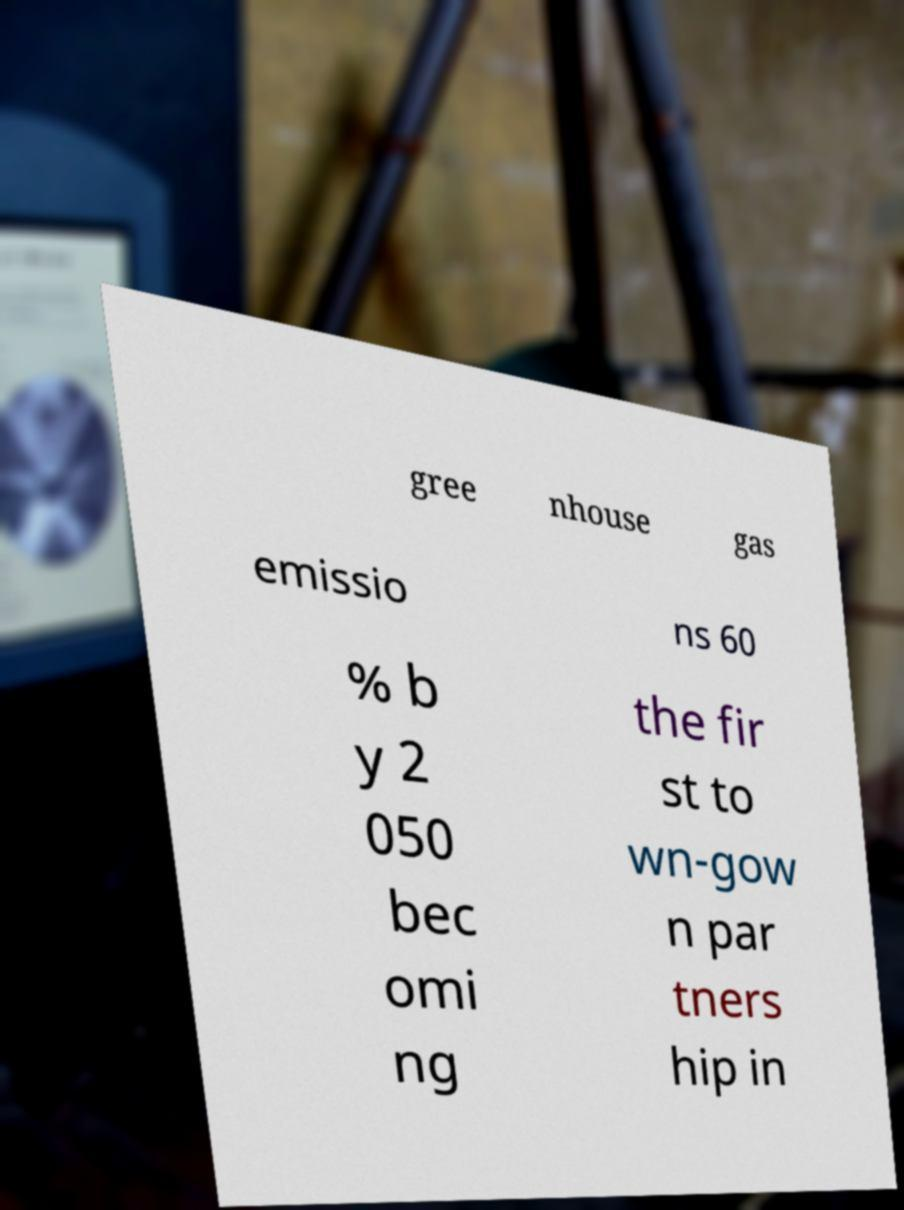Please identify and transcribe the text found in this image. gree nhouse gas emissio ns 60 % b y 2 050 bec omi ng the fir st to wn-gow n par tners hip in 